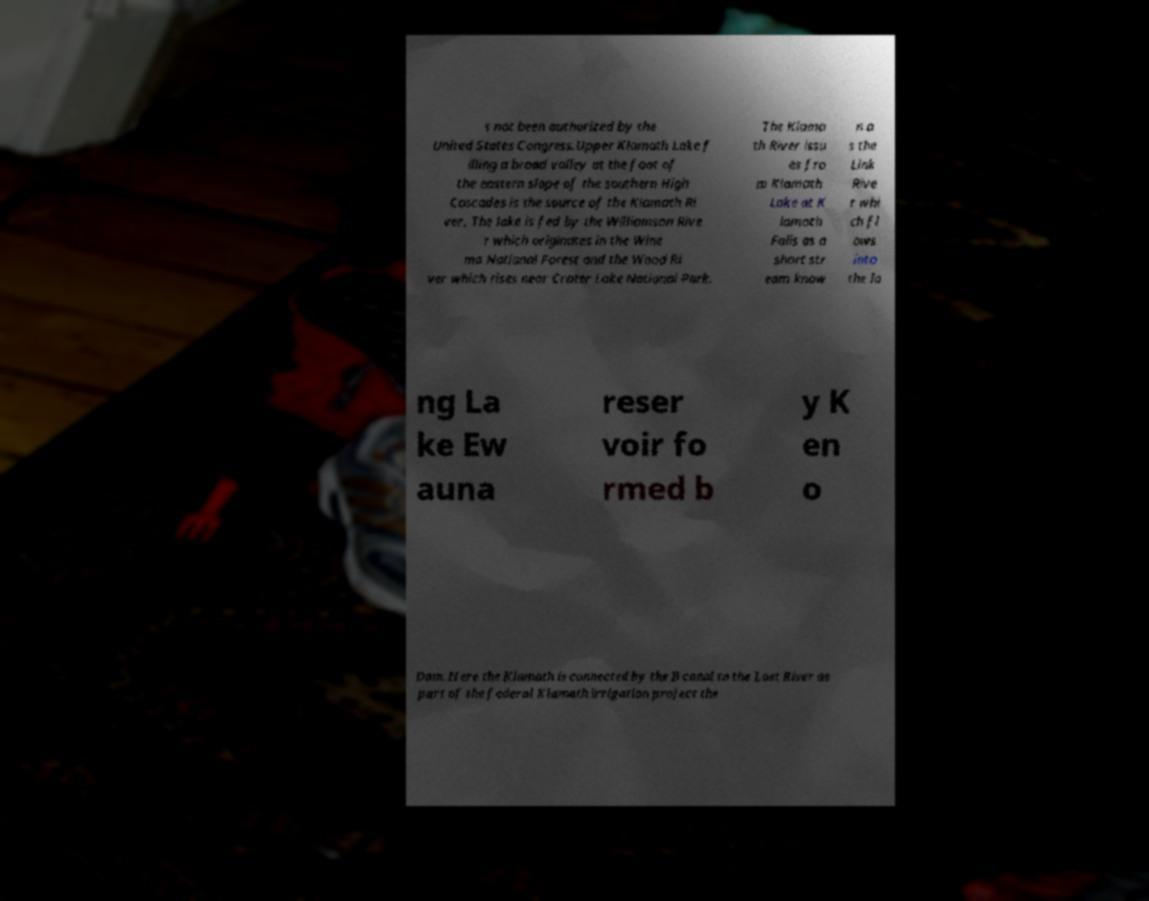Please read and relay the text visible in this image. What does it say? s not been authorized by the United States Congress.Upper Klamath Lake f illing a broad valley at the foot of the eastern slope of the southern High Cascades is the source of the Klamath Ri ver. The lake is fed by the Williamson Rive r which originates in the Wine ma National Forest and the Wood Ri ver which rises near Crater Lake National Park. The Klama th River issu es fro m Klamath Lake at K lamath Falls as a short str eam know n a s the Link Rive r whi ch fl ows into the lo ng La ke Ew auna reser voir fo rmed b y K en o Dam. Here the Klamath is connected by the B canal to the Lost River as part of the federal Klamath irrigation project the 